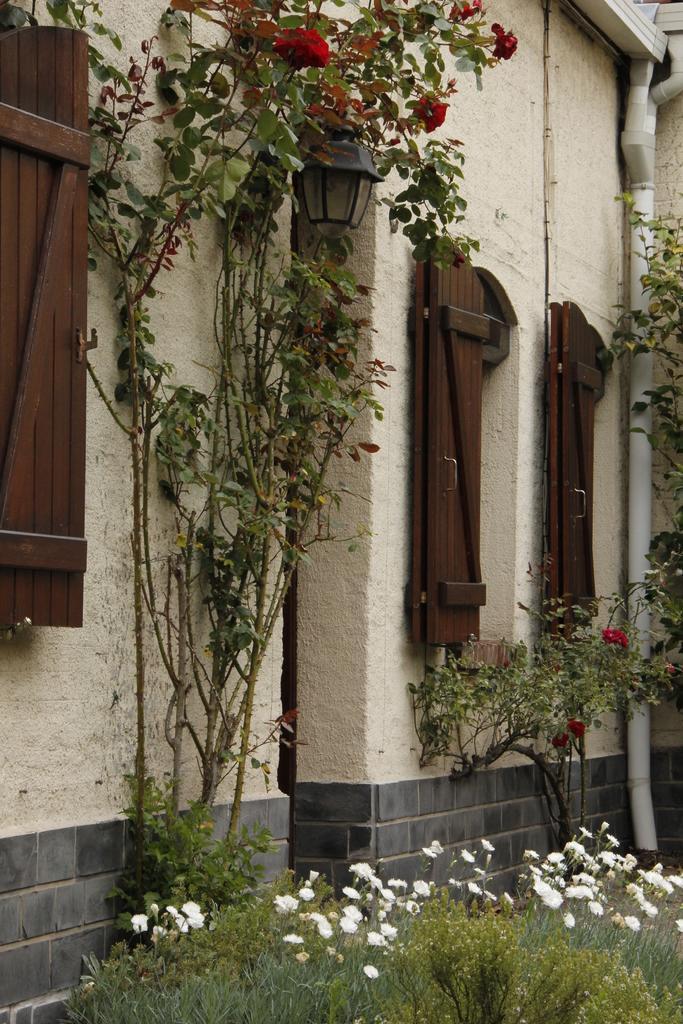Could you give a brief overview of what you see in this image? This image is clicked outside. There is building in the middle. There are plants at the bottom. There are flowers to the plants. 